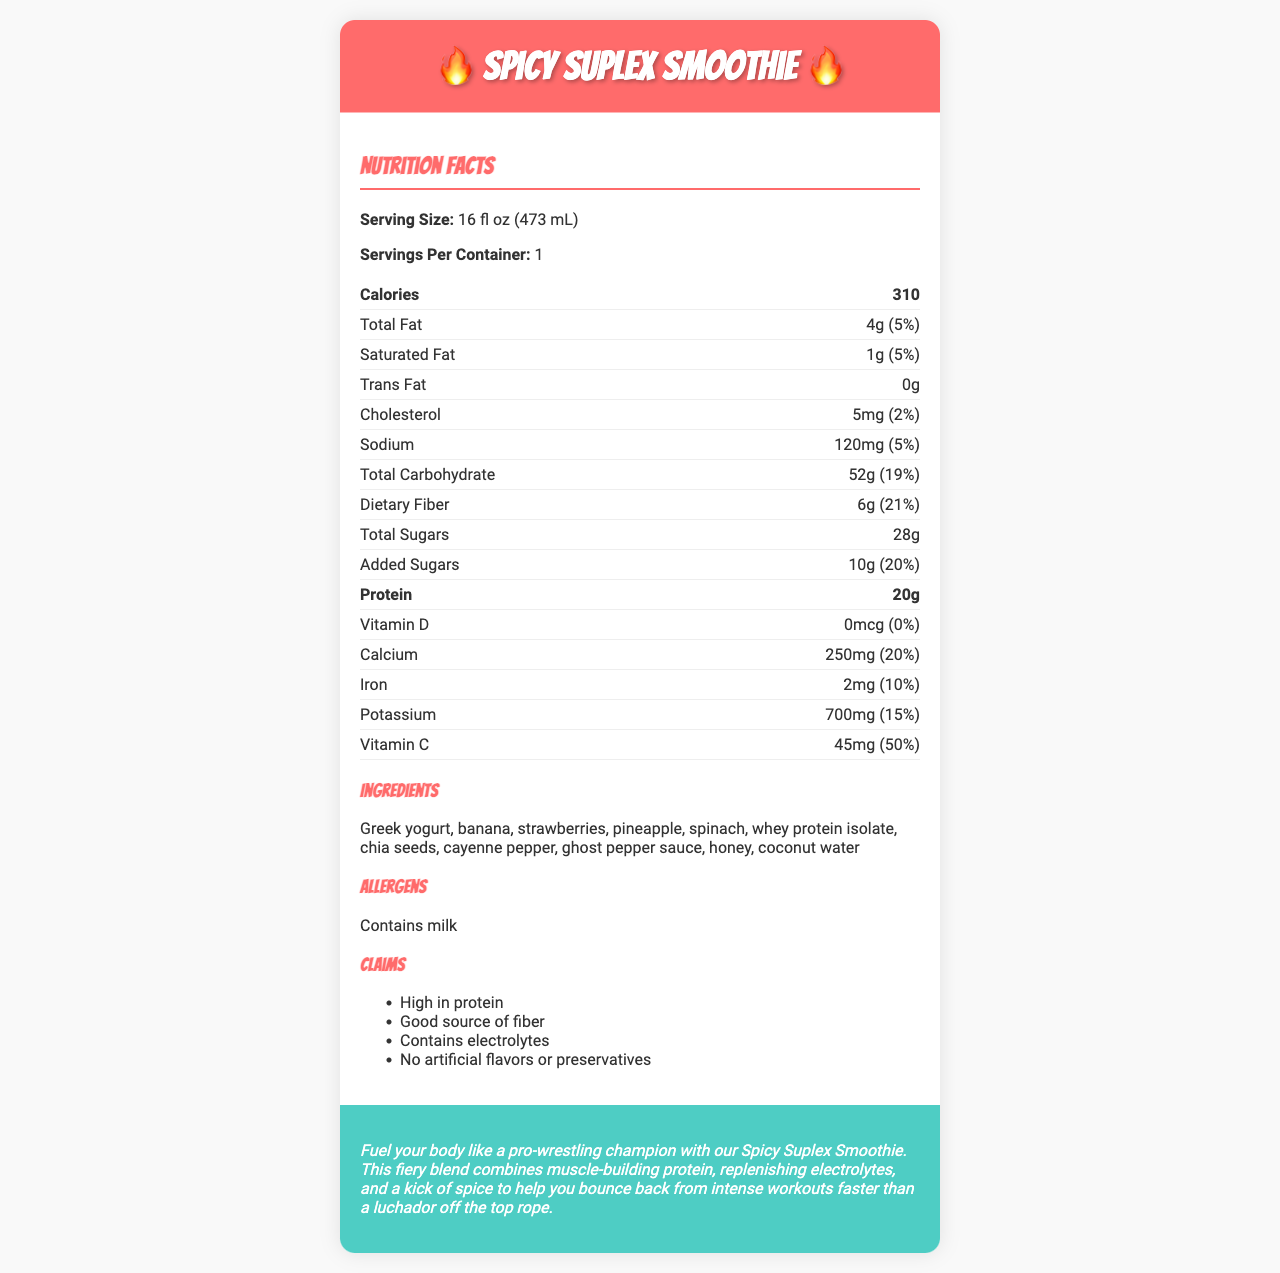what is the serving size of the Spicy Suplex Smoothie? The serving size is listed at the top of the nutrition facts section.
Answer: 16 fl oz (473 mL) how many calories are in one serving of the Spicy Suplex Smoothie? The calories per serving are highlighted in bold within the nutrition facts.
Answer: 310 what is the total amount of dietary fiber per serving? The amount of dietary fiber is listed under the total carbohydrate section.
Answer: 6g how much protein is in the Spicy Suplex Smoothie? The protein content is clearly stated and highlighted in bold within the nutrition facts.
Answer: 20g what percentage of the daily value of calcium does the smoothie provide? The daily value percentage for calcium is listed in the lower part of the nutrition facts.
Answer: 20% which of the following ingredients is NOT in the Spicy Suplex Smoothie? A. Greek yogurt B. Spinach C. Blueberries D. Honey The ingredients list includes Greek yogurt, spinach, and honey, but not blueberries.
Answer: C. Blueberries what is the daily value percentage of vitamin C provided by the smoothie? A. 15% B. 30% C. 50% D. 100% The percentage daily value of vitamin C is stated as 50% in the nutrition facts.
Answer: C. 50% does the Spicy Suplex Smoothie contain any trans fat? According to the nutrition facts, the amount of trans fat is listed as 0g.
Answer: No can people with a milk allergy consume this smoothie? The allergens section states that the product contains milk.
Answer: No how many grams of added sugars are in the Spicy Suplex Smoothie? The amount of added sugars is specified in the nutrition facts.
Answer: 10g summarize the main idea of the Spicy Suplex Smoothie document. The document highlights the nutritional benefits, ingredients, and target audience for the Spicy Suplex Smoothie, emphasizing its suitability for intense workouts with a focus on protein and spiciness.
Answer: The Spicy Suplex Smoothie is a post-workout recovery drink designed for pro-wrestling fans, featuring high protein, electrolytes, and a spicy kick. It offers detailed nutrition facts, a list of ingredients, allergen information, and specific health claims such as being high in protein and fiber. what is the percentage daily value of cholesterol in the Spicy Suplex Smoothie? The daily value percentage for cholesterol is listed as 2% in the nutrition facts.
Answer: 2% what flavor additives are used in the Spicy Suplex Smoothie? The document states there are no artificial flavors or preservatives, but it doesn't specify all possible flavor additives.
Answer: Cannot be determined how many total sugars are in the Spicy Suplex Smoothie? The total amount of sugars is listed under the total carbohydrate section in the nutrition facts.
Answer: 28g how much potassium does the smoothie contain? The amount of potassium is specified in the lower section of the nutrition facts.
Answer: 700mg what makes the Spicy Suplex Smoothie spicy? The ingredients list includes cayenne pepper and ghost pepper sauce, contributing to the smoothie’s spiciness.
Answer: Cayenne pepper and ghost pepper sauce which of the following claims is NOT made about the Spicy Suplex Smoothie? A. High in protein B. Good source of fiber C. Contains electrolytes D. Low in carbohydrates The claims section lists "High in protein," "Good source of fiber," and "Contains electrolytes," but does not mention "Low in carbohydrates."
Answer: D. Low in carbohydrates does the Spicy Suplex Smoothie have any vitamin D? The nutrition facts indicate that the amount of vitamin D is 0mcg, providing 0% of the daily value.
Answer: No 